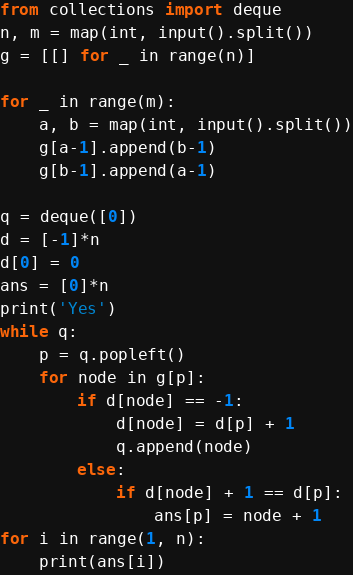<code> <loc_0><loc_0><loc_500><loc_500><_Python_>from collections import deque
n, m = map(int, input().split())
g = [[] for _ in range(n)]

for _ in range(m):
    a, b = map(int, input().split())
    g[a-1].append(b-1)
    g[b-1].append(a-1)

q = deque([0])
d = [-1]*n
d[0] = 0
ans = [0]*n
print('Yes')
while q:
    p = q.popleft()
    for node in g[p]:
        if d[node] == -1:
            d[node] = d[p] + 1
            q.append(node)
        else:
            if d[node] + 1 == d[p]:
                ans[p] = node + 1
for i in range(1, n):
    print(ans[i])</code> 